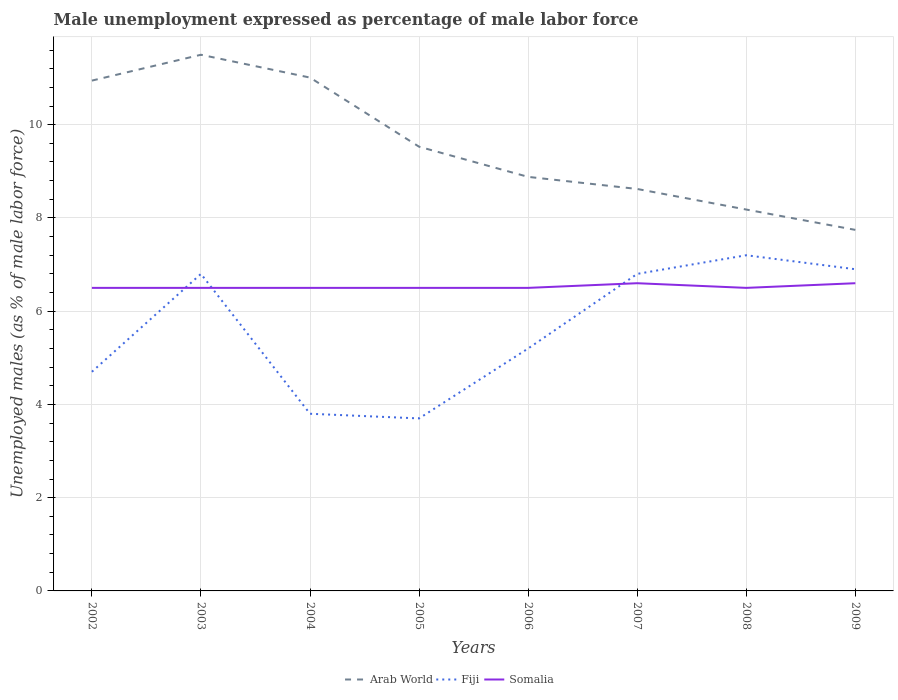How many different coloured lines are there?
Give a very brief answer. 3. Is the number of lines equal to the number of legend labels?
Your answer should be very brief. Yes. What is the total unemployment in males in in Arab World in the graph?
Ensure brevity in your answer.  2.77. What is the difference between the highest and the second highest unemployment in males in in Fiji?
Your answer should be very brief. 3.5. Is the unemployment in males in in Arab World strictly greater than the unemployment in males in in Somalia over the years?
Give a very brief answer. No. How many years are there in the graph?
Your answer should be very brief. 8. Does the graph contain any zero values?
Provide a short and direct response. No. How are the legend labels stacked?
Your answer should be very brief. Horizontal. What is the title of the graph?
Make the answer very short. Male unemployment expressed as percentage of male labor force. What is the label or title of the Y-axis?
Your response must be concise. Unemployed males (as % of male labor force). What is the Unemployed males (as % of male labor force) of Arab World in 2002?
Your answer should be compact. 10.95. What is the Unemployed males (as % of male labor force) of Fiji in 2002?
Your response must be concise. 4.7. What is the Unemployed males (as % of male labor force) in Somalia in 2002?
Give a very brief answer. 6.5. What is the Unemployed males (as % of male labor force) in Arab World in 2003?
Your answer should be compact. 11.5. What is the Unemployed males (as % of male labor force) in Fiji in 2003?
Offer a very short reply. 6.8. What is the Unemployed males (as % of male labor force) in Somalia in 2003?
Make the answer very short. 6.5. What is the Unemployed males (as % of male labor force) in Arab World in 2004?
Ensure brevity in your answer.  11.01. What is the Unemployed males (as % of male labor force) in Fiji in 2004?
Provide a short and direct response. 3.8. What is the Unemployed males (as % of male labor force) in Arab World in 2005?
Offer a very short reply. 9.53. What is the Unemployed males (as % of male labor force) of Fiji in 2005?
Keep it short and to the point. 3.7. What is the Unemployed males (as % of male labor force) in Somalia in 2005?
Your answer should be compact. 6.5. What is the Unemployed males (as % of male labor force) of Arab World in 2006?
Your answer should be compact. 8.88. What is the Unemployed males (as % of male labor force) in Fiji in 2006?
Provide a short and direct response. 5.2. What is the Unemployed males (as % of male labor force) of Somalia in 2006?
Provide a short and direct response. 6.5. What is the Unemployed males (as % of male labor force) of Arab World in 2007?
Offer a very short reply. 8.62. What is the Unemployed males (as % of male labor force) of Fiji in 2007?
Your response must be concise. 6.8. What is the Unemployed males (as % of male labor force) in Somalia in 2007?
Offer a very short reply. 6.6. What is the Unemployed males (as % of male labor force) of Arab World in 2008?
Your answer should be compact. 8.18. What is the Unemployed males (as % of male labor force) of Fiji in 2008?
Make the answer very short. 7.2. What is the Unemployed males (as % of male labor force) in Somalia in 2008?
Your answer should be very brief. 6.5. What is the Unemployed males (as % of male labor force) in Arab World in 2009?
Give a very brief answer. 7.74. What is the Unemployed males (as % of male labor force) in Fiji in 2009?
Your response must be concise. 6.9. What is the Unemployed males (as % of male labor force) in Somalia in 2009?
Offer a very short reply. 6.6. Across all years, what is the maximum Unemployed males (as % of male labor force) in Arab World?
Ensure brevity in your answer.  11.5. Across all years, what is the maximum Unemployed males (as % of male labor force) of Fiji?
Your answer should be compact. 7.2. Across all years, what is the maximum Unemployed males (as % of male labor force) of Somalia?
Ensure brevity in your answer.  6.6. Across all years, what is the minimum Unemployed males (as % of male labor force) of Arab World?
Your answer should be compact. 7.74. Across all years, what is the minimum Unemployed males (as % of male labor force) in Fiji?
Your answer should be very brief. 3.7. What is the total Unemployed males (as % of male labor force) of Arab World in the graph?
Provide a succinct answer. 76.41. What is the total Unemployed males (as % of male labor force) in Fiji in the graph?
Your answer should be very brief. 45.1. What is the total Unemployed males (as % of male labor force) in Somalia in the graph?
Provide a succinct answer. 52.2. What is the difference between the Unemployed males (as % of male labor force) in Arab World in 2002 and that in 2003?
Offer a very short reply. -0.55. What is the difference between the Unemployed males (as % of male labor force) of Somalia in 2002 and that in 2003?
Keep it short and to the point. 0. What is the difference between the Unemployed males (as % of male labor force) of Arab World in 2002 and that in 2004?
Your answer should be compact. -0.06. What is the difference between the Unemployed males (as % of male labor force) in Arab World in 2002 and that in 2005?
Your answer should be compact. 1.42. What is the difference between the Unemployed males (as % of male labor force) of Fiji in 2002 and that in 2005?
Keep it short and to the point. 1. What is the difference between the Unemployed males (as % of male labor force) in Somalia in 2002 and that in 2005?
Make the answer very short. 0. What is the difference between the Unemployed males (as % of male labor force) in Arab World in 2002 and that in 2006?
Keep it short and to the point. 2.06. What is the difference between the Unemployed males (as % of male labor force) in Arab World in 2002 and that in 2007?
Your answer should be very brief. 2.32. What is the difference between the Unemployed males (as % of male labor force) in Arab World in 2002 and that in 2008?
Your answer should be very brief. 2.77. What is the difference between the Unemployed males (as % of male labor force) of Fiji in 2002 and that in 2008?
Offer a very short reply. -2.5. What is the difference between the Unemployed males (as % of male labor force) of Somalia in 2002 and that in 2008?
Provide a succinct answer. 0. What is the difference between the Unemployed males (as % of male labor force) of Arab World in 2002 and that in 2009?
Ensure brevity in your answer.  3.2. What is the difference between the Unemployed males (as % of male labor force) of Arab World in 2003 and that in 2004?
Your answer should be very brief. 0.49. What is the difference between the Unemployed males (as % of male labor force) in Fiji in 2003 and that in 2004?
Keep it short and to the point. 3. What is the difference between the Unemployed males (as % of male labor force) in Arab World in 2003 and that in 2005?
Offer a very short reply. 1.97. What is the difference between the Unemployed males (as % of male labor force) in Somalia in 2003 and that in 2005?
Your answer should be compact. 0. What is the difference between the Unemployed males (as % of male labor force) of Arab World in 2003 and that in 2006?
Your response must be concise. 2.62. What is the difference between the Unemployed males (as % of male labor force) in Somalia in 2003 and that in 2006?
Offer a very short reply. 0. What is the difference between the Unemployed males (as % of male labor force) of Arab World in 2003 and that in 2007?
Your answer should be compact. 2.88. What is the difference between the Unemployed males (as % of male labor force) in Arab World in 2003 and that in 2008?
Provide a succinct answer. 3.32. What is the difference between the Unemployed males (as % of male labor force) of Fiji in 2003 and that in 2008?
Give a very brief answer. -0.4. What is the difference between the Unemployed males (as % of male labor force) of Arab World in 2003 and that in 2009?
Provide a succinct answer. 3.76. What is the difference between the Unemployed males (as % of male labor force) in Arab World in 2004 and that in 2005?
Provide a succinct answer. 1.48. What is the difference between the Unemployed males (as % of male labor force) of Arab World in 2004 and that in 2006?
Your response must be concise. 2.13. What is the difference between the Unemployed males (as % of male labor force) of Somalia in 2004 and that in 2006?
Offer a very short reply. 0. What is the difference between the Unemployed males (as % of male labor force) in Arab World in 2004 and that in 2007?
Offer a terse response. 2.39. What is the difference between the Unemployed males (as % of male labor force) of Arab World in 2004 and that in 2008?
Provide a short and direct response. 2.83. What is the difference between the Unemployed males (as % of male labor force) of Arab World in 2004 and that in 2009?
Offer a terse response. 3.27. What is the difference between the Unemployed males (as % of male labor force) in Fiji in 2004 and that in 2009?
Give a very brief answer. -3.1. What is the difference between the Unemployed males (as % of male labor force) of Somalia in 2004 and that in 2009?
Keep it short and to the point. -0.1. What is the difference between the Unemployed males (as % of male labor force) in Arab World in 2005 and that in 2006?
Give a very brief answer. 0.65. What is the difference between the Unemployed males (as % of male labor force) in Fiji in 2005 and that in 2006?
Make the answer very short. -1.5. What is the difference between the Unemployed males (as % of male labor force) in Somalia in 2005 and that in 2006?
Provide a succinct answer. 0. What is the difference between the Unemployed males (as % of male labor force) in Arab World in 2005 and that in 2007?
Offer a terse response. 0.91. What is the difference between the Unemployed males (as % of male labor force) of Fiji in 2005 and that in 2007?
Keep it short and to the point. -3.1. What is the difference between the Unemployed males (as % of male labor force) of Somalia in 2005 and that in 2007?
Your answer should be very brief. -0.1. What is the difference between the Unemployed males (as % of male labor force) in Arab World in 2005 and that in 2008?
Your response must be concise. 1.35. What is the difference between the Unemployed males (as % of male labor force) of Fiji in 2005 and that in 2008?
Ensure brevity in your answer.  -3.5. What is the difference between the Unemployed males (as % of male labor force) of Somalia in 2005 and that in 2008?
Give a very brief answer. 0. What is the difference between the Unemployed males (as % of male labor force) of Arab World in 2005 and that in 2009?
Your response must be concise. 1.78. What is the difference between the Unemployed males (as % of male labor force) in Fiji in 2005 and that in 2009?
Provide a short and direct response. -3.2. What is the difference between the Unemployed males (as % of male labor force) of Arab World in 2006 and that in 2007?
Offer a very short reply. 0.26. What is the difference between the Unemployed males (as % of male labor force) in Fiji in 2006 and that in 2007?
Ensure brevity in your answer.  -1.6. What is the difference between the Unemployed males (as % of male labor force) in Somalia in 2006 and that in 2007?
Your answer should be compact. -0.1. What is the difference between the Unemployed males (as % of male labor force) in Arab World in 2006 and that in 2008?
Keep it short and to the point. 0.7. What is the difference between the Unemployed males (as % of male labor force) of Fiji in 2006 and that in 2008?
Keep it short and to the point. -2. What is the difference between the Unemployed males (as % of male labor force) in Arab World in 2006 and that in 2009?
Ensure brevity in your answer.  1.14. What is the difference between the Unemployed males (as % of male labor force) of Fiji in 2006 and that in 2009?
Keep it short and to the point. -1.7. What is the difference between the Unemployed males (as % of male labor force) of Arab World in 2007 and that in 2008?
Keep it short and to the point. 0.44. What is the difference between the Unemployed males (as % of male labor force) in Fiji in 2007 and that in 2008?
Offer a terse response. -0.4. What is the difference between the Unemployed males (as % of male labor force) in Arab World in 2007 and that in 2009?
Your response must be concise. 0.88. What is the difference between the Unemployed males (as % of male labor force) in Somalia in 2007 and that in 2009?
Give a very brief answer. 0. What is the difference between the Unemployed males (as % of male labor force) in Arab World in 2008 and that in 2009?
Keep it short and to the point. 0.44. What is the difference between the Unemployed males (as % of male labor force) of Fiji in 2008 and that in 2009?
Provide a short and direct response. 0.3. What is the difference between the Unemployed males (as % of male labor force) in Arab World in 2002 and the Unemployed males (as % of male labor force) in Fiji in 2003?
Offer a terse response. 4.15. What is the difference between the Unemployed males (as % of male labor force) of Arab World in 2002 and the Unemployed males (as % of male labor force) of Somalia in 2003?
Offer a very short reply. 4.45. What is the difference between the Unemployed males (as % of male labor force) of Arab World in 2002 and the Unemployed males (as % of male labor force) of Fiji in 2004?
Make the answer very short. 7.15. What is the difference between the Unemployed males (as % of male labor force) of Arab World in 2002 and the Unemployed males (as % of male labor force) of Somalia in 2004?
Offer a very short reply. 4.45. What is the difference between the Unemployed males (as % of male labor force) of Fiji in 2002 and the Unemployed males (as % of male labor force) of Somalia in 2004?
Provide a succinct answer. -1.8. What is the difference between the Unemployed males (as % of male labor force) of Arab World in 2002 and the Unemployed males (as % of male labor force) of Fiji in 2005?
Offer a terse response. 7.25. What is the difference between the Unemployed males (as % of male labor force) of Arab World in 2002 and the Unemployed males (as % of male labor force) of Somalia in 2005?
Ensure brevity in your answer.  4.45. What is the difference between the Unemployed males (as % of male labor force) in Fiji in 2002 and the Unemployed males (as % of male labor force) in Somalia in 2005?
Offer a terse response. -1.8. What is the difference between the Unemployed males (as % of male labor force) in Arab World in 2002 and the Unemployed males (as % of male labor force) in Fiji in 2006?
Give a very brief answer. 5.75. What is the difference between the Unemployed males (as % of male labor force) of Arab World in 2002 and the Unemployed males (as % of male labor force) of Somalia in 2006?
Your response must be concise. 4.45. What is the difference between the Unemployed males (as % of male labor force) of Fiji in 2002 and the Unemployed males (as % of male labor force) of Somalia in 2006?
Your response must be concise. -1.8. What is the difference between the Unemployed males (as % of male labor force) of Arab World in 2002 and the Unemployed males (as % of male labor force) of Fiji in 2007?
Provide a succinct answer. 4.15. What is the difference between the Unemployed males (as % of male labor force) of Arab World in 2002 and the Unemployed males (as % of male labor force) of Somalia in 2007?
Your answer should be compact. 4.35. What is the difference between the Unemployed males (as % of male labor force) of Arab World in 2002 and the Unemployed males (as % of male labor force) of Fiji in 2008?
Your answer should be very brief. 3.75. What is the difference between the Unemployed males (as % of male labor force) in Arab World in 2002 and the Unemployed males (as % of male labor force) in Somalia in 2008?
Offer a terse response. 4.45. What is the difference between the Unemployed males (as % of male labor force) of Fiji in 2002 and the Unemployed males (as % of male labor force) of Somalia in 2008?
Provide a succinct answer. -1.8. What is the difference between the Unemployed males (as % of male labor force) in Arab World in 2002 and the Unemployed males (as % of male labor force) in Fiji in 2009?
Provide a succinct answer. 4.05. What is the difference between the Unemployed males (as % of male labor force) of Arab World in 2002 and the Unemployed males (as % of male labor force) of Somalia in 2009?
Your answer should be compact. 4.35. What is the difference between the Unemployed males (as % of male labor force) of Fiji in 2002 and the Unemployed males (as % of male labor force) of Somalia in 2009?
Your answer should be compact. -1.9. What is the difference between the Unemployed males (as % of male labor force) in Arab World in 2003 and the Unemployed males (as % of male labor force) in Fiji in 2004?
Your answer should be very brief. 7.7. What is the difference between the Unemployed males (as % of male labor force) in Arab World in 2003 and the Unemployed males (as % of male labor force) in Somalia in 2004?
Ensure brevity in your answer.  5. What is the difference between the Unemployed males (as % of male labor force) of Fiji in 2003 and the Unemployed males (as % of male labor force) of Somalia in 2004?
Give a very brief answer. 0.3. What is the difference between the Unemployed males (as % of male labor force) in Arab World in 2003 and the Unemployed males (as % of male labor force) in Fiji in 2005?
Your response must be concise. 7.8. What is the difference between the Unemployed males (as % of male labor force) of Arab World in 2003 and the Unemployed males (as % of male labor force) of Somalia in 2005?
Ensure brevity in your answer.  5. What is the difference between the Unemployed males (as % of male labor force) in Fiji in 2003 and the Unemployed males (as % of male labor force) in Somalia in 2005?
Give a very brief answer. 0.3. What is the difference between the Unemployed males (as % of male labor force) in Arab World in 2003 and the Unemployed males (as % of male labor force) in Fiji in 2006?
Offer a terse response. 6.3. What is the difference between the Unemployed males (as % of male labor force) in Arab World in 2003 and the Unemployed males (as % of male labor force) in Somalia in 2006?
Keep it short and to the point. 5. What is the difference between the Unemployed males (as % of male labor force) of Fiji in 2003 and the Unemployed males (as % of male labor force) of Somalia in 2006?
Provide a short and direct response. 0.3. What is the difference between the Unemployed males (as % of male labor force) in Arab World in 2003 and the Unemployed males (as % of male labor force) in Fiji in 2007?
Offer a terse response. 4.7. What is the difference between the Unemployed males (as % of male labor force) in Arab World in 2003 and the Unemployed males (as % of male labor force) in Somalia in 2007?
Offer a terse response. 4.9. What is the difference between the Unemployed males (as % of male labor force) in Arab World in 2003 and the Unemployed males (as % of male labor force) in Fiji in 2008?
Make the answer very short. 4.3. What is the difference between the Unemployed males (as % of male labor force) in Arab World in 2003 and the Unemployed males (as % of male labor force) in Somalia in 2008?
Provide a succinct answer. 5. What is the difference between the Unemployed males (as % of male labor force) of Arab World in 2003 and the Unemployed males (as % of male labor force) of Fiji in 2009?
Keep it short and to the point. 4.6. What is the difference between the Unemployed males (as % of male labor force) of Arab World in 2003 and the Unemployed males (as % of male labor force) of Somalia in 2009?
Keep it short and to the point. 4.9. What is the difference between the Unemployed males (as % of male labor force) of Fiji in 2003 and the Unemployed males (as % of male labor force) of Somalia in 2009?
Give a very brief answer. 0.2. What is the difference between the Unemployed males (as % of male labor force) of Arab World in 2004 and the Unemployed males (as % of male labor force) of Fiji in 2005?
Make the answer very short. 7.31. What is the difference between the Unemployed males (as % of male labor force) in Arab World in 2004 and the Unemployed males (as % of male labor force) in Somalia in 2005?
Keep it short and to the point. 4.51. What is the difference between the Unemployed males (as % of male labor force) of Fiji in 2004 and the Unemployed males (as % of male labor force) of Somalia in 2005?
Give a very brief answer. -2.7. What is the difference between the Unemployed males (as % of male labor force) of Arab World in 2004 and the Unemployed males (as % of male labor force) of Fiji in 2006?
Ensure brevity in your answer.  5.81. What is the difference between the Unemployed males (as % of male labor force) in Arab World in 2004 and the Unemployed males (as % of male labor force) in Somalia in 2006?
Your answer should be compact. 4.51. What is the difference between the Unemployed males (as % of male labor force) of Arab World in 2004 and the Unemployed males (as % of male labor force) of Fiji in 2007?
Your response must be concise. 4.21. What is the difference between the Unemployed males (as % of male labor force) of Arab World in 2004 and the Unemployed males (as % of male labor force) of Somalia in 2007?
Provide a succinct answer. 4.41. What is the difference between the Unemployed males (as % of male labor force) in Fiji in 2004 and the Unemployed males (as % of male labor force) in Somalia in 2007?
Keep it short and to the point. -2.8. What is the difference between the Unemployed males (as % of male labor force) in Arab World in 2004 and the Unemployed males (as % of male labor force) in Fiji in 2008?
Make the answer very short. 3.81. What is the difference between the Unemployed males (as % of male labor force) in Arab World in 2004 and the Unemployed males (as % of male labor force) in Somalia in 2008?
Ensure brevity in your answer.  4.51. What is the difference between the Unemployed males (as % of male labor force) in Fiji in 2004 and the Unemployed males (as % of male labor force) in Somalia in 2008?
Provide a short and direct response. -2.7. What is the difference between the Unemployed males (as % of male labor force) of Arab World in 2004 and the Unemployed males (as % of male labor force) of Fiji in 2009?
Keep it short and to the point. 4.11. What is the difference between the Unemployed males (as % of male labor force) of Arab World in 2004 and the Unemployed males (as % of male labor force) of Somalia in 2009?
Make the answer very short. 4.41. What is the difference between the Unemployed males (as % of male labor force) of Arab World in 2005 and the Unemployed males (as % of male labor force) of Fiji in 2006?
Offer a very short reply. 4.33. What is the difference between the Unemployed males (as % of male labor force) in Arab World in 2005 and the Unemployed males (as % of male labor force) in Somalia in 2006?
Your response must be concise. 3.03. What is the difference between the Unemployed males (as % of male labor force) of Arab World in 2005 and the Unemployed males (as % of male labor force) of Fiji in 2007?
Offer a terse response. 2.73. What is the difference between the Unemployed males (as % of male labor force) in Arab World in 2005 and the Unemployed males (as % of male labor force) in Somalia in 2007?
Your response must be concise. 2.93. What is the difference between the Unemployed males (as % of male labor force) of Arab World in 2005 and the Unemployed males (as % of male labor force) of Fiji in 2008?
Provide a short and direct response. 2.33. What is the difference between the Unemployed males (as % of male labor force) of Arab World in 2005 and the Unemployed males (as % of male labor force) of Somalia in 2008?
Offer a very short reply. 3.03. What is the difference between the Unemployed males (as % of male labor force) of Arab World in 2005 and the Unemployed males (as % of male labor force) of Fiji in 2009?
Ensure brevity in your answer.  2.63. What is the difference between the Unemployed males (as % of male labor force) in Arab World in 2005 and the Unemployed males (as % of male labor force) in Somalia in 2009?
Your answer should be very brief. 2.93. What is the difference between the Unemployed males (as % of male labor force) in Arab World in 2006 and the Unemployed males (as % of male labor force) in Fiji in 2007?
Provide a short and direct response. 2.08. What is the difference between the Unemployed males (as % of male labor force) in Arab World in 2006 and the Unemployed males (as % of male labor force) in Somalia in 2007?
Your answer should be compact. 2.28. What is the difference between the Unemployed males (as % of male labor force) of Fiji in 2006 and the Unemployed males (as % of male labor force) of Somalia in 2007?
Ensure brevity in your answer.  -1.4. What is the difference between the Unemployed males (as % of male labor force) of Arab World in 2006 and the Unemployed males (as % of male labor force) of Fiji in 2008?
Make the answer very short. 1.68. What is the difference between the Unemployed males (as % of male labor force) of Arab World in 2006 and the Unemployed males (as % of male labor force) of Somalia in 2008?
Ensure brevity in your answer.  2.38. What is the difference between the Unemployed males (as % of male labor force) in Fiji in 2006 and the Unemployed males (as % of male labor force) in Somalia in 2008?
Your answer should be compact. -1.3. What is the difference between the Unemployed males (as % of male labor force) in Arab World in 2006 and the Unemployed males (as % of male labor force) in Fiji in 2009?
Provide a succinct answer. 1.98. What is the difference between the Unemployed males (as % of male labor force) of Arab World in 2006 and the Unemployed males (as % of male labor force) of Somalia in 2009?
Your answer should be compact. 2.28. What is the difference between the Unemployed males (as % of male labor force) of Arab World in 2007 and the Unemployed males (as % of male labor force) of Fiji in 2008?
Give a very brief answer. 1.42. What is the difference between the Unemployed males (as % of male labor force) in Arab World in 2007 and the Unemployed males (as % of male labor force) in Somalia in 2008?
Provide a short and direct response. 2.12. What is the difference between the Unemployed males (as % of male labor force) in Fiji in 2007 and the Unemployed males (as % of male labor force) in Somalia in 2008?
Provide a succinct answer. 0.3. What is the difference between the Unemployed males (as % of male labor force) in Arab World in 2007 and the Unemployed males (as % of male labor force) in Fiji in 2009?
Give a very brief answer. 1.72. What is the difference between the Unemployed males (as % of male labor force) in Arab World in 2007 and the Unemployed males (as % of male labor force) in Somalia in 2009?
Give a very brief answer. 2.02. What is the difference between the Unemployed males (as % of male labor force) in Fiji in 2007 and the Unemployed males (as % of male labor force) in Somalia in 2009?
Your answer should be compact. 0.2. What is the difference between the Unemployed males (as % of male labor force) of Arab World in 2008 and the Unemployed males (as % of male labor force) of Fiji in 2009?
Your answer should be very brief. 1.28. What is the difference between the Unemployed males (as % of male labor force) in Arab World in 2008 and the Unemployed males (as % of male labor force) in Somalia in 2009?
Your answer should be compact. 1.58. What is the difference between the Unemployed males (as % of male labor force) of Fiji in 2008 and the Unemployed males (as % of male labor force) of Somalia in 2009?
Ensure brevity in your answer.  0.6. What is the average Unemployed males (as % of male labor force) in Arab World per year?
Your answer should be very brief. 9.55. What is the average Unemployed males (as % of male labor force) in Fiji per year?
Provide a succinct answer. 5.64. What is the average Unemployed males (as % of male labor force) of Somalia per year?
Give a very brief answer. 6.53. In the year 2002, what is the difference between the Unemployed males (as % of male labor force) of Arab World and Unemployed males (as % of male labor force) of Fiji?
Offer a terse response. 6.25. In the year 2002, what is the difference between the Unemployed males (as % of male labor force) in Arab World and Unemployed males (as % of male labor force) in Somalia?
Keep it short and to the point. 4.45. In the year 2002, what is the difference between the Unemployed males (as % of male labor force) in Fiji and Unemployed males (as % of male labor force) in Somalia?
Provide a short and direct response. -1.8. In the year 2003, what is the difference between the Unemployed males (as % of male labor force) in Arab World and Unemployed males (as % of male labor force) in Fiji?
Offer a very short reply. 4.7. In the year 2003, what is the difference between the Unemployed males (as % of male labor force) in Arab World and Unemployed males (as % of male labor force) in Somalia?
Provide a succinct answer. 5. In the year 2003, what is the difference between the Unemployed males (as % of male labor force) in Fiji and Unemployed males (as % of male labor force) in Somalia?
Your answer should be compact. 0.3. In the year 2004, what is the difference between the Unemployed males (as % of male labor force) of Arab World and Unemployed males (as % of male labor force) of Fiji?
Offer a very short reply. 7.21. In the year 2004, what is the difference between the Unemployed males (as % of male labor force) of Arab World and Unemployed males (as % of male labor force) of Somalia?
Provide a succinct answer. 4.51. In the year 2004, what is the difference between the Unemployed males (as % of male labor force) of Fiji and Unemployed males (as % of male labor force) of Somalia?
Provide a succinct answer. -2.7. In the year 2005, what is the difference between the Unemployed males (as % of male labor force) of Arab World and Unemployed males (as % of male labor force) of Fiji?
Your response must be concise. 5.83. In the year 2005, what is the difference between the Unemployed males (as % of male labor force) in Arab World and Unemployed males (as % of male labor force) in Somalia?
Provide a short and direct response. 3.03. In the year 2005, what is the difference between the Unemployed males (as % of male labor force) in Fiji and Unemployed males (as % of male labor force) in Somalia?
Give a very brief answer. -2.8. In the year 2006, what is the difference between the Unemployed males (as % of male labor force) of Arab World and Unemployed males (as % of male labor force) of Fiji?
Make the answer very short. 3.68. In the year 2006, what is the difference between the Unemployed males (as % of male labor force) of Arab World and Unemployed males (as % of male labor force) of Somalia?
Provide a short and direct response. 2.38. In the year 2007, what is the difference between the Unemployed males (as % of male labor force) in Arab World and Unemployed males (as % of male labor force) in Fiji?
Your answer should be compact. 1.82. In the year 2007, what is the difference between the Unemployed males (as % of male labor force) in Arab World and Unemployed males (as % of male labor force) in Somalia?
Provide a short and direct response. 2.02. In the year 2008, what is the difference between the Unemployed males (as % of male labor force) of Arab World and Unemployed males (as % of male labor force) of Fiji?
Your response must be concise. 0.98. In the year 2008, what is the difference between the Unemployed males (as % of male labor force) of Arab World and Unemployed males (as % of male labor force) of Somalia?
Your response must be concise. 1.68. In the year 2008, what is the difference between the Unemployed males (as % of male labor force) of Fiji and Unemployed males (as % of male labor force) of Somalia?
Offer a terse response. 0.7. In the year 2009, what is the difference between the Unemployed males (as % of male labor force) of Arab World and Unemployed males (as % of male labor force) of Fiji?
Keep it short and to the point. 0.84. In the year 2009, what is the difference between the Unemployed males (as % of male labor force) of Arab World and Unemployed males (as % of male labor force) of Somalia?
Your answer should be very brief. 1.14. What is the ratio of the Unemployed males (as % of male labor force) in Arab World in 2002 to that in 2003?
Give a very brief answer. 0.95. What is the ratio of the Unemployed males (as % of male labor force) in Fiji in 2002 to that in 2003?
Provide a succinct answer. 0.69. What is the ratio of the Unemployed males (as % of male labor force) in Arab World in 2002 to that in 2004?
Offer a very short reply. 0.99. What is the ratio of the Unemployed males (as % of male labor force) in Fiji in 2002 to that in 2004?
Keep it short and to the point. 1.24. What is the ratio of the Unemployed males (as % of male labor force) of Arab World in 2002 to that in 2005?
Your answer should be compact. 1.15. What is the ratio of the Unemployed males (as % of male labor force) in Fiji in 2002 to that in 2005?
Provide a short and direct response. 1.27. What is the ratio of the Unemployed males (as % of male labor force) in Somalia in 2002 to that in 2005?
Offer a terse response. 1. What is the ratio of the Unemployed males (as % of male labor force) in Arab World in 2002 to that in 2006?
Your answer should be very brief. 1.23. What is the ratio of the Unemployed males (as % of male labor force) in Fiji in 2002 to that in 2006?
Your answer should be very brief. 0.9. What is the ratio of the Unemployed males (as % of male labor force) in Arab World in 2002 to that in 2007?
Your response must be concise. 1.27. What is the ratio of the Unemployed males (as % of male labor force) of Fiji in 2002 to that in 2007?
Make the answer very short. 0.69. What is the ratio of the Unemployed males (as % of male labor force) in Somalia in 2002 to that in 2007?
Your answer should be compact. 0.98. What is the ratio of the Unemployed males (as % of male labor force) of Arab World in 2002 to that in 2008?
Keep it short and to the point. 1.34. What is the ratio of the Unemployed males (as % of male labor force) in Fiji in 2002 to that in 2008?
Ensure brevity in your answer.  0.65. What is the ratio of the Unemployed males (as % of male labor force) in Somalia in 2002 to that in 2008?
Offer a terse response. 1. What is the ratio of the Unemployed males (as % of male labor force) of Arab World in 2002 to that in 2009?
Keep it short and to the point. 1.41. What is the ratio of the Unemployed males (as % of male labor force) of Fiji in 2002 to that in 2009?
Keep it short and to the point. 0.68. What is the ratio of the Unemployed males (as % of male labor force) in Somalia in 2002 to that in 2009?
Your answer should be compact. 0.98. What is the ratio of the Unemployed males (as % of male labor force) of Arab World in 2003 to that in 2004?
Provide a succinct answer. 1.04. What is the ratio of the Unemployed males (as % of male labor force) of Fiji in 2003 to that in 2004?
Provide a short and direct response. 1.79. What is the ratio of the Unemployed males (as % of male labor force) of Somalia in 2003 to that in 2004?
Ensure brevity in your answer.  1. What is the ratio of the Unemployed males (as % of male labor force) of Arab World in 2003 to that in 2005?
Keep it short and to the point. 1.21. What is the ratio of the Unemployed males (as % of male labor force) of Fiji in 2003 to that in 2005?
Your answer should be very brief. 1.84. What is the ratio of the Unemployed males (as % of male labor force) of Arab World in 2003 to that in 2006?
Your response must be concise. 1.29. What is the ratio of the Unemployed males (as % of male labor force) in Fiji in 2003 to that in 2006?
Offer a very short reply. 1.31. What is the ratio of the Unemployed males (as % of male labor force) in Somalia in 2003 to that in 2006?
Offer a very short reply. 1. What is the ratio of the Unemployed males (as % of male labor force) of Arab World in 2003 to that in 2007?
Provide a succinct answer. 1.33. What is the ratio of the Unemployed males (as % of male labor force) in Fiji in 2003 to that in 2007?
Ensure brevity in your answer.  1. What is the ratio of the Unemployed males (as % of male labor force) of Somalia in 2003 to that in 2007?
Make the answer very short. 0.98. What is the ratio of the Unemployed males (as % of male labor force) in Arab World in 2003 to that in 2008?
Ensure brevity in your answer.  1.41. What is the ratio of the Unemployed males (as % of male labor force) in Fiji in 2003 to that in 2008?
Your response must be concise. 0.94. What is the ratio of the Unemployed males (as % of male labor force) in Somalia in 2003 to that in 2008?
Make the answer very short. 1. What is the ratio of the Unemployed males (as % of male labor force) in Arab World in 2003 to that in 2009?
Your answer should be very brief. 1.49. What is the ratio of the Unemployed males (as % of male labor force) of Fiji in 2003 to that in 2009?
Offer a terse response. 0.99. What is the ratio of the Unemployed males (as % of male labor force) in Arab World in 2004 to that in 2005?
Your answer should be compact. 1.16. What is the ratio of the Unemployed males (as % of male labor force) of Arab World in 2004 to that in 2006?
Ensure brevity in your answer.  1.24. What is the ratio of the Unemployed males (as % of male labor force) in Fiji in 2004 to that in 2006?
Give a very brief answer. 0.73. What is the ratio of the Unemployed males (as % of male labor force) in Arab World in 2004 to that in 2007?
Your answer should be compact. 1.28. What is the ratio of the Unemployed males (as % of male labor force) in Fiji in 2004 to that in 2007?
Give a very brief answer. 0.56. What is the ratio of the Unemployed males (as % of male labor force) of Arab World in 2004 to that in 2008?
Provide a short and direct response. 1.35. What is the ratio of the Unemployed males (as % of male labor force) of Fiji in 2004 to that in 2008?
Provide a succinct answer. 0.53. What is the ratio of the Unemployed males (as % of male labor force) in Somalia in 2004 to that in 2008?
Offer a very short reply. 1. What is the ratio of the Unemployed males (as % of male labor force) in Arab World in 2004 to that in 2009?
Your response must be concise. 1.42. What is the ratio of the Unemployed males (as % of male labor force) in Fiji in 2004 to that in 2009?
Your answer should be very brief. 0.55. What is the ratio of the Unemployed males (as % of male labor force) of Arab World in 2005 to that in 2006?
Give a very brief answer. 1.07. What is the ratio of the Unemployed males (as % of male labor force) in Fiji in 2005 to that in 2006?
Your response must be concise. 0.71. What is the ratio of the Unemployed males (as % of male labor force) in Arab World in 2005 to that in 2007?
Ensure brevity in your answer.  1.11. What is the ratio of the Unemployed males (as % of male labor force) of Fiji in 2005 to that in 2007?
Provide a succinct answer. 0.54. What is the ratio of the Unemployed males (as % of male labor force) of Arab World in 2005 to that in 2008?
Make the answer very short. 1.16. What is the ratio of the Unemployed males (as % of male labor force) of Fiji in 2005 to that in 2008?
Ensure brevity in your answer.  0.51. What is the ratio of the Unemployed males (as % of male labor force) of Arab World in 2005 to that in 2009?
Provide a short and direct response. 1.23. What is the ratio of the Unemployed males (as % of male labor force) in Fiji in 2005 to that in 2009?
Ensure brevity in your answer.  0.54. What is the ratio of the Unemployed males (as % of male labor force) of Arab World in 2006 to that in 2007?
Keep it short and to the point. 1.03. What is the ratio of the Unemployed males (as % of male labor force) in Fiji in 2006 to that in 2007?
Your answer should be very brief. 0.76. What is the ratio of the Unemployed males (as % of male labor force) of Arab World in 2006 to that in 2008?
Keep it short and to the point. 1.09. What is the ratio of the Unemployed males (as % of male labor force) in Fiji in 2006 to that in 2008?
Your answer should be very brief. 0.72. What is the ratio of the Unemployed males (as % of male labor force) of Somalia in 2006 to that in 2008?
Your answer should be very brief. 1. What is the ratio of the Unemployed males (as % of male labor force) in Arab World in 2006 to that in 2009?
Your response must be concise. 1.15. What is the ratio of the Unemployed males (as % of male labor force) in Fiji in 2006 to that in 2009?
Provide a succinct answer. 0.75. What is the ratio of the Unemployed males (as % of male labor force) in Arab World in 2007 to that in 2008?
Offer a very short reply. 1.05. What is the ratio of the Unemployed males (as % of male labor force) in Somalia in 2007 to that in 2008?
Ensure brevity in your answer.  1.02. What is the ratio of the Unemployed males (as % of male labor force) of Arab World in 2007 to that in 2009?
Your answer should be very brief. 1.11. What is the ratio of the Unemployed males (as % of male labor force) in Fiji in 2007 to that in 2009?
Make the answer very short. 0.99. What is the ratio of the Unemployed males (as % of male labor force) of Somalia in 2007 to that in 2009?
Your answer should be very brief. 1. What is the ratio of the Unemployed males (as % of male labor force) of Arab World in 2008 to that in 2009?
Ensure brevity in your answer.  1.06. What is the ratio of the Unemployed males (as % of male labor force) of Fiji in 2008 to that in 2009?
Your answer should be compact. 1.04. What is the difference between the highest and the second highest Unemployed males (as % of male labor force) in Arab World?
Provide a short and direct response. 0.49. What is the difference between the highest and the second highest Unemployed males (as % of male labor force) in Fiji?
Your response must be concise. 0.3. What is the difference between the highest and the second highest Unemployed males (as % of male labor force) in Somalia?
Give a very brief answer. 0. What is the difference between the highest and the lowest Unemployed males (as % of male labor force) of Arab World?
Your answer should be compact. 3.76. What is the difference between the highest and the lowest Unemployed males (as % of male labor force) of Somalia?
Your response must be concise. 0.1. 